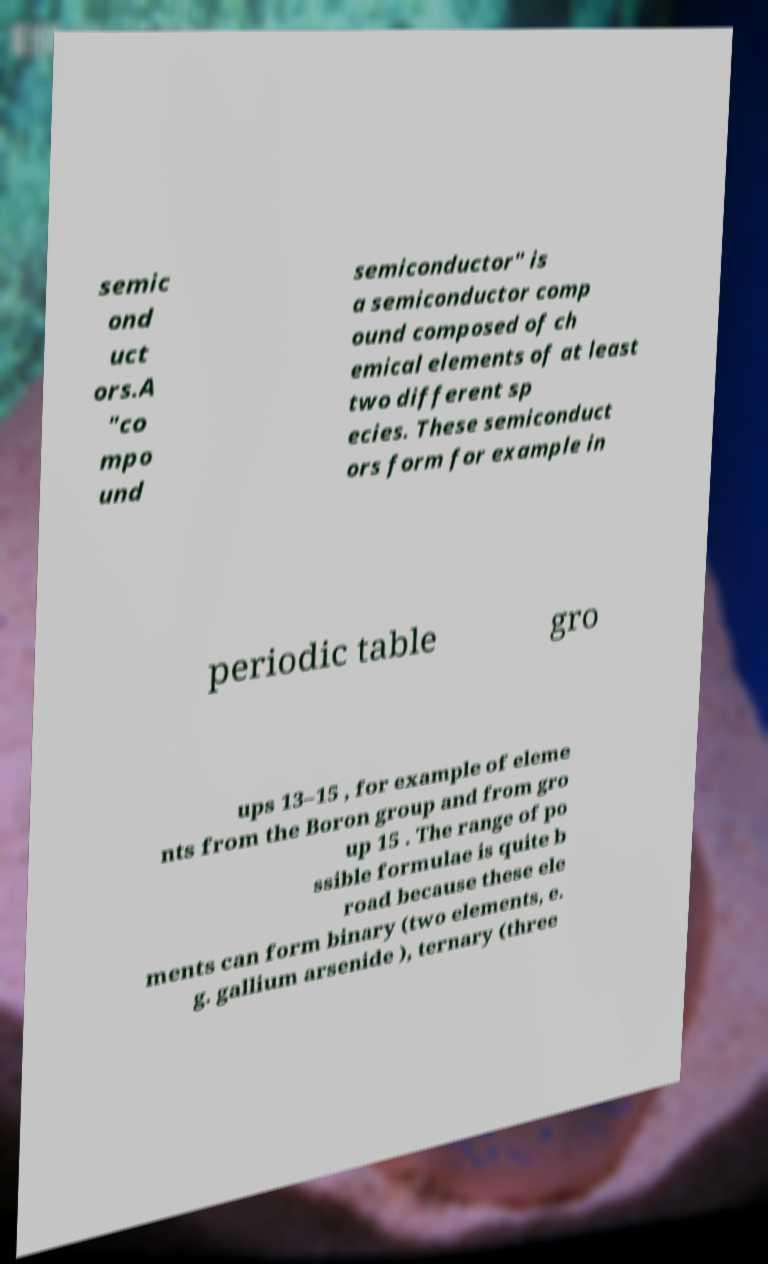Please read and relay the text visible in this image. What does it say? semic ond uct ors.A "co mpo und semiconductor" is a semiconductor comp ound composed of ch emical elements of at least two different sp ecies. These semiconduct ors form for example in periodic table gro ups 13–15 , for example of eleme nts from the Boron group and from gro up 15 . The range of po ssible formulae is quite b road because these ele ments can form binary (two elements, e. g. gallium arsenide ), ternary (three 